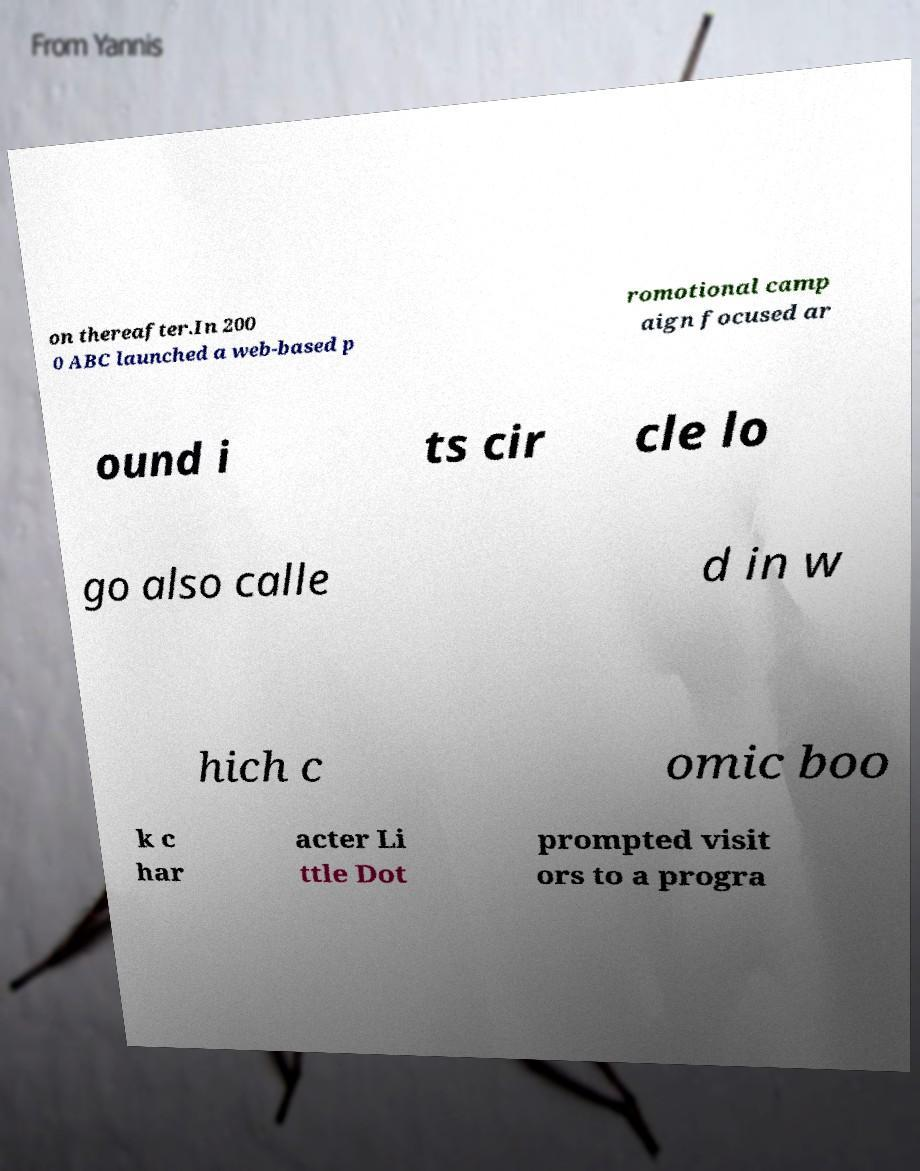I need the written content from this picture converted into text. Can you do that? on thereafter.In 200 0 ABC launched a web-based p romotional camp aign focused ar ound i ts cir cle lo go also calle d in w hich c omic boo k c har acter Li ttle Dot prompted visit ors to a progra 